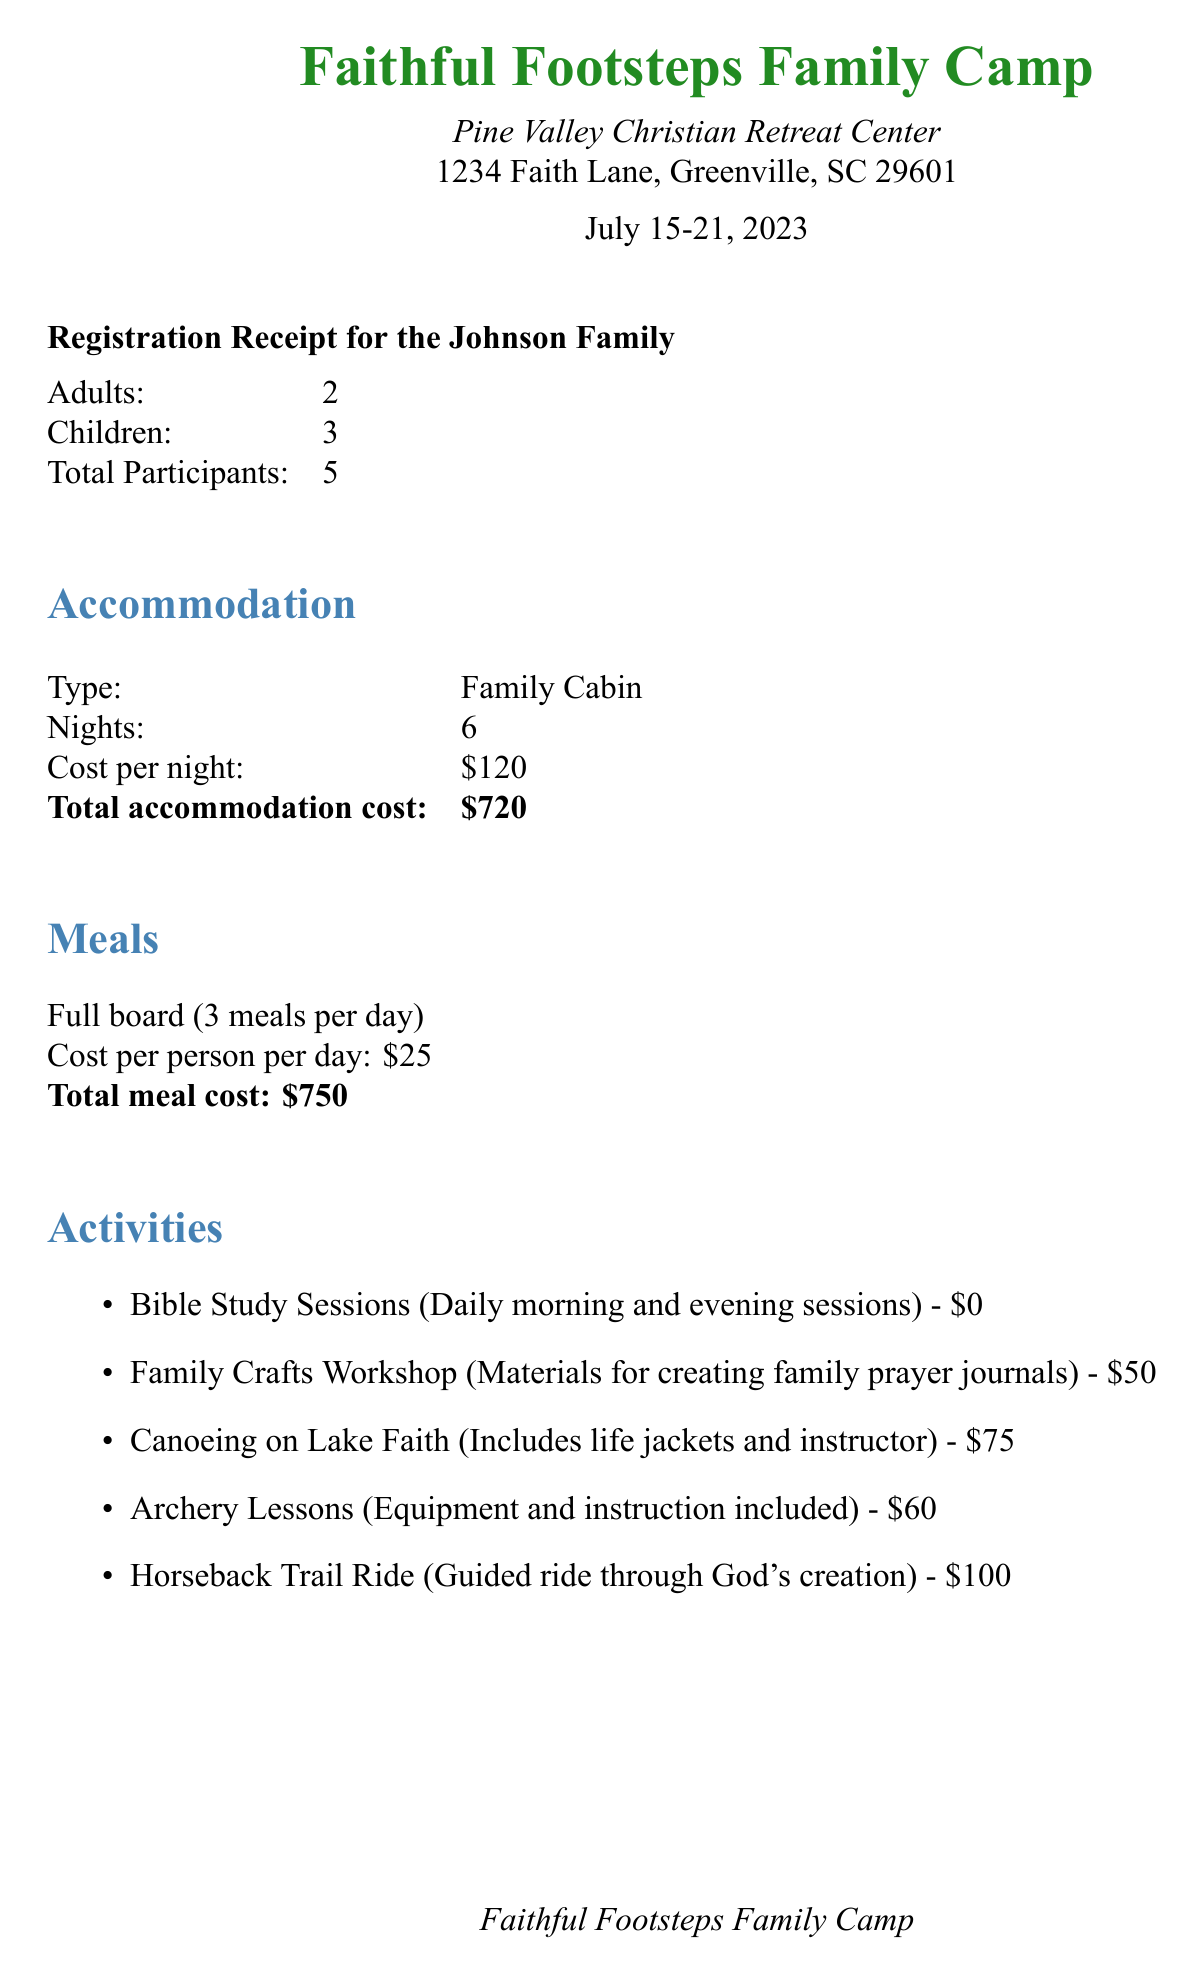What is the name of the camp? The camp's name is listed prominently at the top of the document.
Answer: Faithful Footsteps Family Camp What are the camp dates? The registration receipt provides the specific dates of the camp.
Answer: July 15-21, 2023 How many adults are registered? The number of adults is specified in the registration details section.
Answer: 2 What is the total cost for accommodation? The total accommodation cost is calculated and stated in the accommodation section.
Answer: $720 What is the balance due after the deposit? The balance due is stated in the payment summary section.
Answer: $1,285 What discount is provided for early registration? The document specifies the discount for early bird registration.
Answer: $50 How many children are registered? The number of children is mentioned in the registration details section.
Answer: 3 What is included in the Family Portrait Session? The details about the family portrait session are described in the additional services section.
Answer: Professional photographer, one 8x10 print included Is there a refund for cancellation after 14 days? The cancellation policy states the conditions for refund.
Answer: No refund for cancellations less than 14 days before camp 